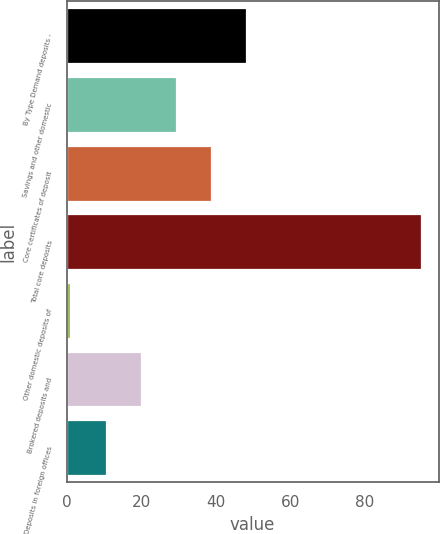<chart> <loc_0><loc_0><loc_500><loc_500><bar_chart><fcel>By Type Demand deposits -<fcel>Savings and other domestic<fcel>Core certificates of deposit<fcel>Total core deposits<fcel>Other domestic deposits of<fcel>Brokered deposits and<fcel>Deposits in foreign offices<nl><fcel>48<fcel>29.2<fcel>38.6<fcel>95<fcel>1<fcel>19.8<fcel>10.4<nl></chart> 